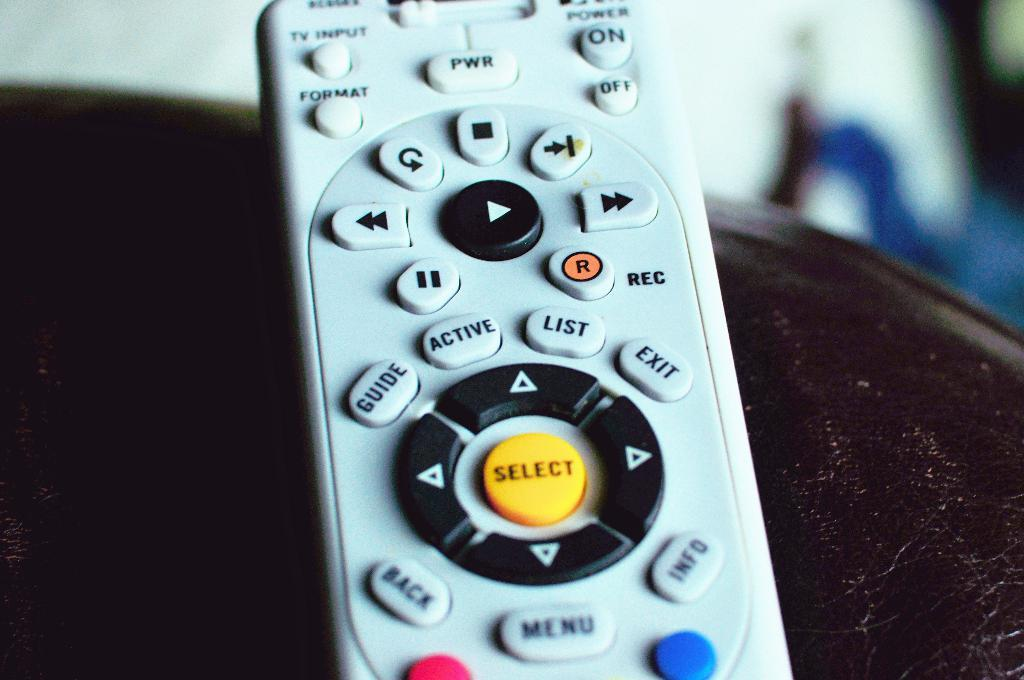<image>
Write a terse but informative summary of the picture. A remote control with a center select button between directional buttons. 